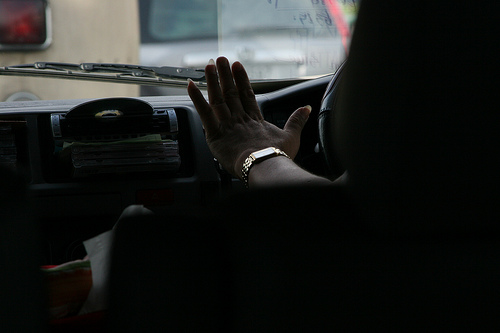<image>
Is the watch on the dashboard? No. The watch is not positioned on the dashboard. They may be near each other, but the watch is not supported by or resting on top of the dashboard. 